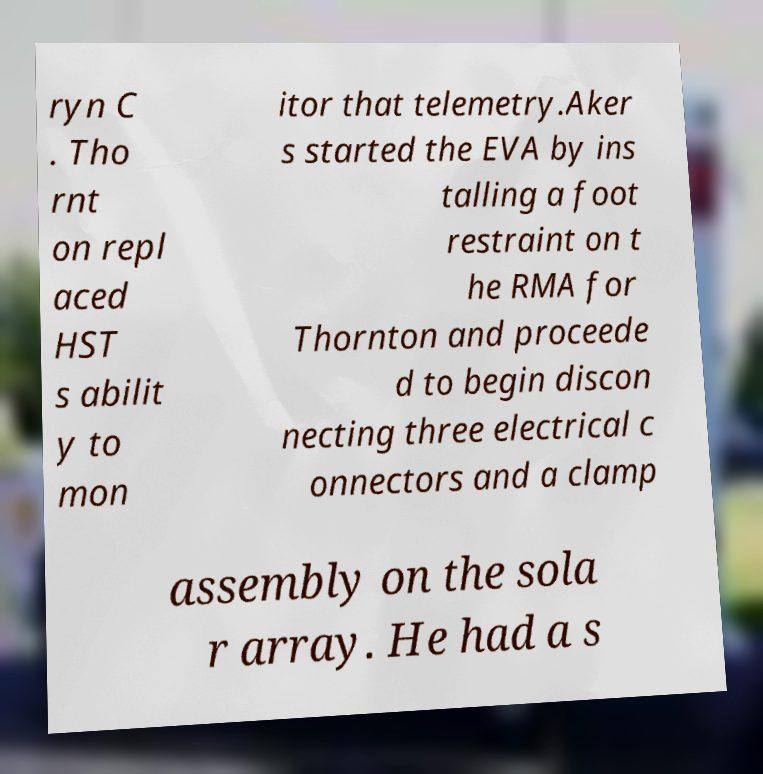What messages or text are displayed in this image? I need them in a readable, typed format. ryn C . Tho rnt on repl aced HST s abilit y to mon itor that telemetry.Aker s started the EVA by ins talling a foot restraint on t he RMA for Thornton and proceede d to begin discon necting three electrical c onnectors and a clamp assembly on the sola r array. He had a s 